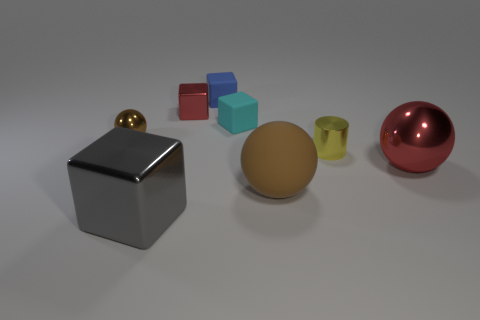There is a large metallic object that is to the right of the small red metal cube; is its color the same as the metal cube behind the small metallic cylinder?
Provide a short and direct response. Yes. There is a object that is in front of the big red metal thing and left of the big brown matte thing; what color is it?
Ensure brevity in your answer.  Gray. What number of objects are large metal blocks or tiny metal objects that are on the left side of the brown rubber thing?
Provide a succinct answer. 3. What is the material of the sphere that is in front of the metallic sphere in front of the brown object behind the brown matte object?
Make the answer very short. Rubber. Is there anything else that is made of the same material as the big brown sphere?
Give a very brief answer. Yes. Do the object on the right side of the tiny metal cylinder and the tiny metallic cube have the same color?
Give a very brief answer. Yes. How many gray things are rubber balls or big cubes?
Give a very brief answer. 1. What number of other things are there of the same shape as the brown rubber object?
Give a very brief answer. 2. Are the large brown thing and the blue block made of the same material?
Offer a very short reply. Yes. What is the material of the small cube that is both right of the red cube and behind the small cyan matte object?
Your response must be concise. Rubber. 